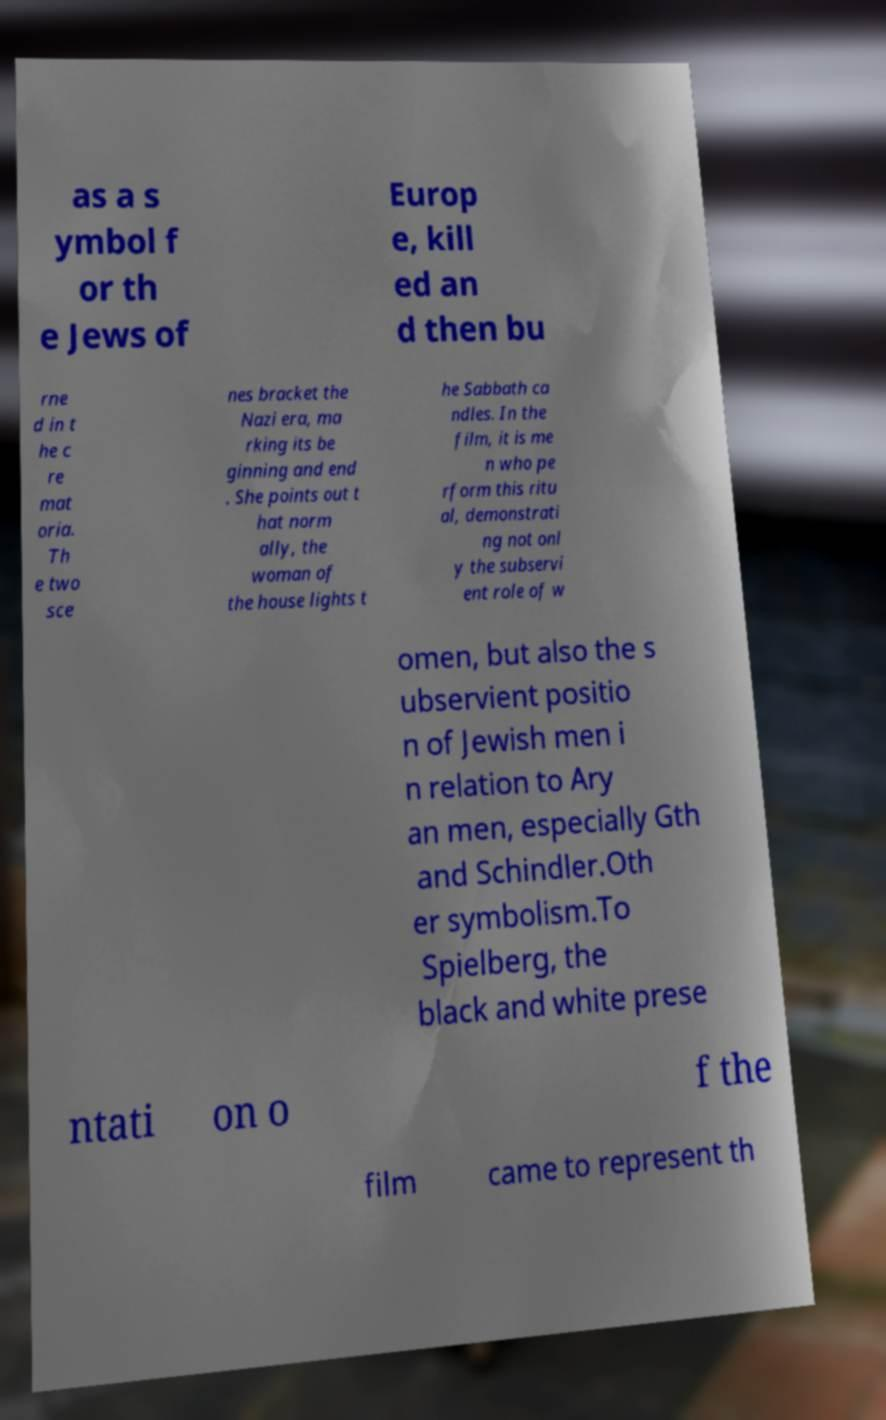Could you assist in decoding the text presented in this image and type it out clearly? as a s ymbol f or th e Jews of Europ e, kill ed an d then bu rne d in t he c re mat oria. Th e two sce nes bracket the Nazi era, ma rking its be ginning and end . She points out t hat norm ally, the woman of the house lights t he Sabbath ca ndles. In the film, it is me n who pe rform this ritu al, demonstrati ng not onl y the subservi ent role of w omen, but also the s ubservient positio n of Jewish men i n relation to Ary an men, especially Gth and Schindler.Oth er symbolism.To Spielberg, the black and white prese ntati on o f the film came to represent th 